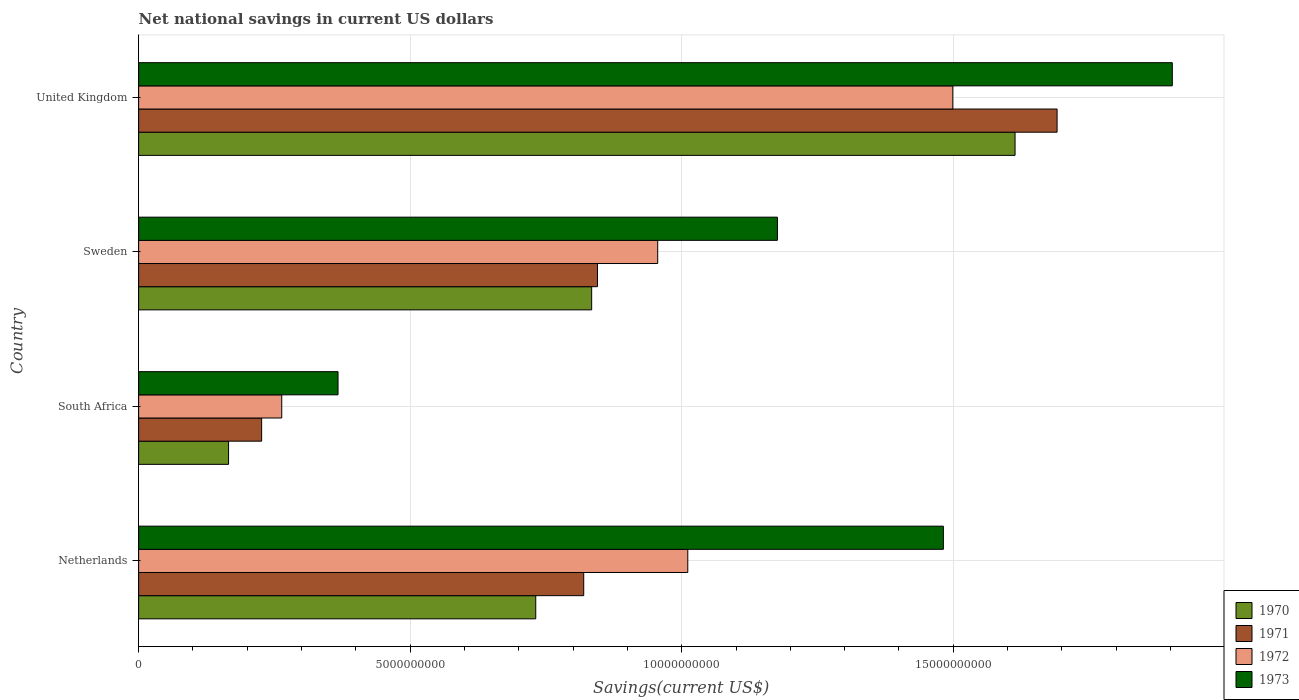How many different coloured bars are there?
Your response must be concise. 4. Are the number of bars per tick equal to the number of legend labels?
Give a very brief answer. Yes. Are the number of bars on each tick of the Y-axis equal?
Make the answer very short. Yes. How many bars are there on the 2nd tick from the bottom?
Offer a terse response. 4. What is the label of the 1st group of bars from the top?
Ensure brevity in your answer.  United Kingdom. In how many cases, is the number of bars for a given country not equal to the number of legend labels?
Your answer should be compact. 0. What is the net national savings in 1971 in South Africa?
Give a very brief answer. 2.27e+09. Across all countries, what is the maximum net national savings in 1971?
Give a very brief answer. 1.69e+1. Across all countries, what is the minimum net national savings in 1971?
Ensure brevity in your answer.  2.27e+09. In which country was the net national savings in 1970 minimum?
Your answer should be very brief. South Africa. What is the total net national savings in 1971 in the graph?
Give a very brief answer. 3.58e+1. What is the difference between the net national savings in 1972 in Netherlands and that in United Kingdom?
Offer a terse response. -4.88e+09. What is the difference between the net national savings in 1971 in United Kingdom and the net national savings in 1972 in Netherlands?
Offer a terse response. 6.80e+09. What is the average net national savings in 1972 per country?
Your answer should be compact. 9.32e+09. What is the difference between the net national savings in 1971 and net national savings in 1970 in United Kingdom?
Keep it short and to the point. 7.74e+08. What is the ratio of the net national savings in 1970 in South Africa to that in United Kingdom?
Keep it short and to the point. 0.1. Is the net national savings in 1973 in Netherlands less than that in Sweden?
Your answer should be very brief. No. What is the difference between the highest and the second highest net national savings in 1973?
Provide a succinct answer. 4.22e+09. What is the difference between the highest and the lowest net national savings in 1972?
Make the answer very short. 1.24e+1. What does the 3rd bar from the top in Sweden represents?
Your response must be concise. 1971. Is it the case that in every country, the sum of the net national savings in 1971 and net national savings in 1970 is greater than the net national savings in 1972?
Offer a very short reply. Yes. What is the difference between two consecutive major ticks on the X-axis?
Your answer should be compact. 5.00e+09. Are the values on the major ticks of X-axis written in scientific E-notation?
Make the answer very short. No. Does the graph contain grids?
Your answer should be very brief. Yes. How many legend labels are there?
Your response must be concise. 4. What is the title of the graph?
Provide a succinct answer. Net national savings in current US dollars. Does "1972" appear as one of the legend labels in the graph?
Provide a succinct answer. Yes. What is the label or title of the X-axis?
Offer a very short reply. Savings(current US$). What is the label or title of the Y-axis?
Make the answer very short. Country. What is the Savings(current US$) of 1970 in Netherlands?
Your answer should be very brief. 7.31e+09. What is the Savings(current US$) of 1971 in Netherlands?
Keep it short and to the point. 8.20e+09. What is the Savings(current US$) in 1972 in Netherlands?
Keep it short and to the point. 1.01e+1. What is the Savings(current US$) in 1973 in Netherlands?
Your response must be concise. 1.48e+1. What is the Savings(current US$) of 1970 in South Africa?
Give a very brief answer. 1.66e+09. What is the Savings(current US$) of 1971 in South Africa?
Offer a very short reply. 2.27e+09. What is the Savings(current US$) of 1972 in South Africa?
Your answer should be compact. 2.64e+09. What is the Savings(current US$) of 1973 in South Africa?
Keep it short and to the point. 3.67e+09. What is the Savings(current US$) of 1970 in Sweden?
Your answer should be very brief. 8.34e+09. What is the Savings(current US$) of 1971 in Sweden?
Give a very brief answer. 8.45e+09. What is the Savings(current US$) of 1972 in Sweden?
Give a very brief answer. 9.56e+09. What is the Savings(current US$) of 1973 in Sweden?
Your answer should be very brief. 1.18e+1. What is the Savings(current US$) of 1970 in United Kingdom?
Keep it short and to the point. 1.61e+1. What is the Savings(current US$) of 1971 in United Kingdom?
Make the answer very short. 1.69e+1. What is the Savings(current US$) of 1972 in United Kingdom?
Provide a succinct answer. 1.50e+1. What is the Savings(current US$) of 1973 in United Kingdom?
Offer a very short reply. 1.90e+1. Across all countries, what is the maximum Savings(current US$) of 1970?
Offer a terse response. 1.61e+1. Across all countries, what is the maximum Savings(current US$) of 1971?
Offer a very short reply. 1.69e+1. Across all countries, what is the maximum Savings(current US$) in 1972?
Your answer should be very brief. 1.50e+1. Across all countries, what is the maximum Savings(current US$) of 1973?
Offer a terse response. 1.90e+1. Across all countries, what is the minimum Savings(current US$) of 1970?
Your answer should be very brief. 1.66e+09. Across all countries, what is the minimum Savings(current US$) in 1971?
Offer a very short reply. 2.27e+09. Across all countries, what is the minimum Savings(current US$) of 1972?
Keep it short and to the point. 2.64e+09. Across all countries, what is the minimum Savings(current US$) in 1973?
Your answer should be compact. 3.67e+09. What is the total Savings(current US$) of 1970 in the graph?
Your response must be concise. 3.34e+1. What is the total Savings(current US$) of 1971 in the graph?
Provide a succinct answer. 3.58e+1. What is the total Savings(current US$) in 1972 in the graph?
Provide a succinct answer. 3.73e+1. What is the total Savings(current US$) of 1973 in the graph?
Give a very brief answer. 4.93e+1. What is the difference between the Savings(current US$) in 1970 in Netherlands and that in South Africa?
Offer a terse response. 5.66e+09. What is the difference between the Savings(current US$) of 1971 in Netherlands and that in South Africa?
Give a very brief answer. 5.93e+09. What is the difference between the Savings(current US$) in 1972 in Netherlands and that in South Africa?
Your answer should be compact. 7.48e+09. What is the difference between the Savings(current US$) in 1973 in Netherlands and that in South Africa?
Give a very brief answer. 1.11e+1. What is the difference between the Savings(current US$) of 1970 in Netherlands and that in Sweden?
Ensure brevity in your answer.  -1.03e+09. What is the difference between the Savings(current US$) of 1971 in Netherlands and that in Sweden?
Offer a terse response. -2.53e+08. What is the difference between the Savings(current US$) in 1972 in Netherlands and that in Sweden?
Your answer should be very brief. 5.54e+08. What is the difference between the Savings(current US$) in 1973 in Netherlands and that in Sweden?
Offer a very short reply. 3.06e+09. What is the difference between the Savings(current US$) in 1970 in Netherlands and that in United Kingdom?
Keep it short and to the point. -8.83e+09. What is the difference between the Savings(current US$) of 1971 in Netherlands and that in United Kingdom?
Your answer should be compact. -8.72e+09. What is the difference between the Savings(current US$) in 1972 in Netherlands and that in United Kingdom?
Provide a short and direct response. -4.88e+09. What is the difference between the Savings(current US$) in 1973 in Netherlands and that in United Kingdom?
Offer a very short reply. -4.22e+09. What is the difference between the Savings(current US$) in 1970 in South Africa and that in Sweden?
Provide a succinct answer. -6.69e+09. What is the difference between the Savings(current US$) of 1971 in South Africa and that in Sweden?
Ensure brevity in your answer.  -6.18e+09. What is the difference between the Savings(current US$) of 1972 in South Africa and that in Sweden?
Your response must be concise. -6.92e+09. What is the difference between the Savings(current US$) of 1973 in South Africa and that in Sweden?
Your answer should be very brief. -8.09e+09. What is the difference between the Savings(current US$) of 1970 in South Africa and that in United Kingdom?
Provide a short and direct response. -1.45e+1. What is the difference between the Savings(current US$) in 1971 in South Africa and that in United Kingdom?
Give a very brief answer. -1.46e+1. What is the difference between the Savings(current US$) of 1972 in South Africa and that in United Kingdom?
Provide a succinct answer. -1.24e+1. What is the difference between the Savings(current US$) of 1973 in South Africa and that in United Kingdom?
Your answer should be compact. -1.54e+1. What is the difference between the Savings(current US$) of 1970 in Sweden and that in United Kingdom?
Make the answer very short. -7.80e+09. What is the difference between the Savings(current US$) in 1971 in Sweden and that in United Kingdom?
Your response must be concise. -8.46e+09. What is the difference between the Savings(current US$) in 1972 in Sweden and that in United Kingdom?
Provide a short and direct response. -5.43e+09. What is the difference between the Savings(current US$) in 1973 in Sweden and that in United Kingdom?
Your answer should be compact. -7.27e+09. What is the difference between the Savings(current US$) in 1970 in Netherlands and the Savings(current US$) in 1971 in South Africa?
Offer a terse response. 5.05e+09. What is the difference between the Savings(current US$) in 1970 in Netherlands and the Savings(current US$) in 1972 in South Africa?
Provide a succinct answer. 4.68e+09. What is the difference between the Savings(current US$) in 1970 in Netherlands and the Savings(current US$) in 1973 in South Africa?
Offer a terse response. 3.64e+09. What is the difference between the Savings(current US$) in 1971 in Netherlands and the Savings(current US$) in 1972 in South Africa?
Your answer should be very brief. 5.56e+09. What is the difference between the Savings(current US$) in 1971 in Netherlands and the Savings(current US$) in 1973 in South Africa?
Ensure brevity in your answer.  4.52e+09. What is the difference between the Savings(current US$) of 1972 in Netherlands and the Savings(current US$) of 1973 in South Africa?
Ensure brevity in your answer.  6.44e+09. What is the difference between the Savings(current US$) of 1970 in Netherlands and the Savings(current US$) of 1971 in Sweden?
Give a very brief answer. -1.14e+09. What is the difference between the Savings(current US$) in 1970 in Netherlands and the Savings(current US$) in 1972 in Sweden?
Offer a very short reply. -2.25e+09. What is the difference between the Savings(current US$) of 1970 in Netherlands and the Savings(current US$) of 1973 in Sweden?
Offer a very short reply. -4.45e+09. What is the difference between the Savings(current US$) of 1971 in Netherlands and the Savings(current US$) of 1972 in Sweden?
Offer a terse response. -1.36e+09. What is the difference between the Savings(current US$) of 1971 in Netherlands and the Savings(current US$) of 1973 in Sweden?
Offer a very short reply. -3.57e+09. What is the difference between the Savings(current US$) of 1972 in Netherlands and the Savings(current US$) of 1973 in Sweden?
Your answer should be very brief. -1.65e+09. What is the difference between the Savings(current US$) in 1970 in Netherlands and the Savings(current US$) in 1971 in United Kingdom?
Your response must be concise. -9.60e+09. What is the difference between the Savings(current US$) in 1970 in Netherlands and the Savings(current US$) in 1972 in United Kingdom?
Make the answer very short. -7.68e+09. What is the difference between the Savings(current US$) in 1970 in Netherlands and the Savings(current US$) in 1973 in United Kingdom?
Keep it short and to the point. -1.17e+1. What is the difference between the Savings(current US$) in 1971 in Netherlands and the Savings(current US$) in 1972 in United Kingdom?
Keep it short and to the point. -6.80e+09. What is the difference between the Savings(current US$) of 1971 in Netherlands and the Savings(current US$) of 1973 in United Kingdom?
Make the answer very short. -1.08e+1. What is the difference between the Savings(current US$) of 1972 in Netherlands and the Savings(current US$) of 1973 in United Kingdom?
Give a very brief answer. -8.92e+09. What is the difference between the Savings(current US$) in 1970 in South Africa and the Savings(current US$) in 1971 in Sweden?
Your answer should be compact. -6.79e+09. What is the difference between the Savings(current US$) of 1970 in South Africa and the Savings(current US$) of 1972 in Sweden?
Provide a short and direct response. -7.90e+09. What is the difference between the Savings(current US$) in 1970 in South Africa and the Savings(current US$) in 1973 in Sweden?
Offer a very short reply. -1.01e+1. What is the difference between the Savings(current US$) in 1971 in South Africa and the Savings(current US$) in 1972 in Sweden?
Keep it short and to the point. -7.29e+09. What is the difference between the Savings(current US$) of 1971 in South Africa and the Savings(current US$) of 1973 in Sweden?
Your answer should be very brief. -9.50e+09. What is the difference between the Savings(current US$) of 1972 in South Africa and the Savings(current US$) of 1973 in Sweden?
Offer a terse response. -9.13e+09. What is the difference between the Savings(current US$) in 1970 in South Africa and the Savings(current US$) in 1971 in United Kingdom?
Give a very brief answer. -1.53e+1. What is the difference between the Savings(current US$) in 1970 in South Africa and the Savings(current US$) in 1972 in United Kingdom?
Offer a terse response. -1.33e+1. What is the difference between the Savings(current US$) of 1970 in South Africa and the Savings(current US$) of 1973 in United Kingdom?
Your answer should be very brief. -1.74e+1. What is the difference between the Savings(current US$) in 1971 in South Africa and the Savings(current US$) in 1972 in United Kingdom?
Offer a very short reply. -1.27e+1. What is the difference between the Savings(current US$) in 1971 in South Africa and the Savings(current US$) in 1973 in United Kingdom?
Keep it short and to the point. -1.68e+1. What is the difference between the Savings(current US$) in 1972 in South Africa and the Savings(current US$) in 1973 in United Kingdom?
Your answer should be very brief. -1.64e+1. What is the difference between the Savings(current US$) in 1970 in Sweden and the Savings(current US$) in 1971 in United Kingdom?
Provide a short and direct response. -8.57e+09. What is the difference between the Savings(current US$) of 1970 in Sweden and the Savings(current US$) of 1972 in United Kingdom?
Give a very brief answer. -6.65e+09. What is the difference between the Savings(current US$) of 1970 in Sweden and the Savings(current US$) of 1973 in United Kingdom?
Offer a very short reply. -1.07e+1. What is the difference between the Savings(current US$) in 1971 in Sweden and the Savings(current US$) in 1972 in United Kingdom?
Provide a succinct answer. -6.54e+09. What is the difference between the Savings(current US$) in 1971 in Sweden and the Savings(current US$) in 1973 in United Kingdom?
Offer a terse response. -1.06e+1. What is the difference between the Savings(current US$) of 1972 in Sweden and the Savings(current US$) of 1973 in United Kingdom?
Provide a succinct answer. -9.48e+09. What is the average Savings(current US$) of 1970 per country?
Your answer should be compact. 8.36e+09. What is the average Savings(current US$) of 1971 per country?
Make the answer very short. 8.96e+09. What is the average Savings(current US$) in 1972 per country?
Your answer should be compact. 9.32e+09. What is the average Savings(current US$) of 1973 per country?
Your response must be concise. 1.23e+1. What is the difference between the Savings(current US$) of 1970 and Savings(current US$) of 1971 in Netherlands?
Your answer should be compact. -8.83e+08. What is the difference between the Savings(current US$) of 1970 and Savings(current US$) of 1972 in Netherlands?
Offer a terse response. -2.80e+09. What is the difference between the Savings(current US$) in 1970 and Savings(current US$) in 1973 in Netherlands?
Ensure brevity in your answer.  -7.51e+09. What is the difference between the Savings(current US$) in 1971 and Savings(current US$) in 1972 in Netherlands?
Provide a short and direct response. -1.92e+09. What is the difference between the Savings(current US$) in 1971 and Savings(current US$) in 1973 in Netherlands?
Your answer should be compact. -6.62e+09. What is the difference between the Savings(current US$) in 1972 and Savings(current US$) in 1973 in Netherlands?
Your answer should be very brief. -4.71e+09. What is the difference between the Savings(current US$) in 1970 and Savings(current US$) in 1971 in South Africa?
Ensure brevity in your answer.  -6.09e+08. What is the difference between the Savings(current US$) in 1970 and Savings(current US$) in 1972 in South Africa?
Give a very brief answer. -9.79e+08. What is the difference between the Savings(current US$) in 1970 and Savings(current US$) in 1973 in South Africa?
Your answer should be compact. -2.02e+09. What is the difference between the Savings(current US$) of 1971 and Savings(current US$) of 1972 in South Africa?
Provide a succinct answer. -3.70e+08. What is the difference between the Savings(current US$) in 1971 and Savings(current US$) in 1973 in South Africa?
Offer a terse response. -1.41e+09. What is the difference between the Savings(current US$) of 1972 and Savings(current US$) of 1973 in South Africa?
Your response must be concise. -1.04e+09. What is the difference between the Savings(current US$) of 1970 and Savings(current US$) of 1971 in Sweden?
Offer a terse response. -1.07e+08. What is the difference between the Savings(current US$) of 1970 and Savings(current US$) of 1972 in Sweden?
Make the answer very short. -1.22e+09. What is the difference between the Savings(current US$) of 1970 and Savings(current US$) of 1973 in Sweden?
Provide a short and direct response. -3.42e+09. What is the difference between the Savings(current US$) in 1971 and Savings(current US$) in 1972 in Sweden?
Make the answer very short. -1.11e+09. What is the difference between the Savings(current US$) of 1971 and Savings(current US$) of 1973 in Sweden?
Keep it short and to the point. -3.31e+09. What is the difference between the Savings(current US$) of 1972 and Savings(current US$) of 1973 in Sweden?
Ensure brevity in your answer.  -2.20e+09. What is the difference between the Savings(current US$) in 1970 and Savings(current US$) in 1971 in United Kingdom?
Provide a succinct answer. -7.74e+08. What is the difference between the Savings(current US$) of 1970 and Savings(current US$) of 1972 in United Kingdom?
Provide a short and direct response. 1.15e+09. What is the difference between the Savings(current US$) of 1970 and Savings(current US$) of 1973 in United Kingdom?
Offer a terse response. -2.90e+09. What is the difference between the Savings(current US$) in 1971 and Savings(current US$) in 1972 in United Kingdom?
Provide a short and direct response. 1.92e+09. What is the difference between the Savings(current US$) of 1971 and Savings(current US$) of 1973 in United Kingdom?
Give a very brief answer. -2.12e+09. What is the difference between the Savings(current US$) in 1972 and Savings(current US$) in 1973 in United Kingdom?
Provide a short and direct response. -4.04e+09. What is the ratio of the Savings(current US$) in 1970 in Netherlands to that in South Africa?
Offer a very short reply. 4.42. What is the ratio of the Savings(current US$) of 1971 in Netherlands to that in South Africa?
Make the answer very short. 3.62. What is the ratio of the Savings(current US$) in 1972 in Netherlands to that in South Africa?
Ensure brevity in your answer.  3.84. What is the ratio of the Savings(current US$) in 1973 in Netherlands to that in South Africa?
Offer a terse response. 4.04. What is the ratio of the Savings(current US$) of 1970 in Netherlands to that in Sweden?
Provide a short and direct response. 0.88. What is the ratio of the Savings(current US$) of 1972 in Netherlands to that in Sweden?
Make the answer very short. 1.06. What is the ratio of the Savings(current US$) of 1973 in Netherlands to that in Sweden?
Offer a very short reply. 1.26. What is the ratio of the Savings(current US$) of 1970 in Netherlands to that in United Kingdom?
Offer a very short reply. 0.45. What is the ratio of the Savings(current US$) of 1971 in Netherlands to that in United Kingdom?
Your response must be concise. 0.48. What is the ratio of the Savings(current US$) of 1972 in Netherlands to that in United Kingdom?
Ensure brevity in your answer.  0.67. What is the ratio of the Savings(current US$) in 1973 in Netherlands to that in United Kingdom?
Keep it short and to the point. 0.78. What is the ratio of the Savings(current US$) of 1970 in South Africa to that in Sweden?
Give a very brief answer. 0.2. What is the ratio of the Savings(current US$) in 1971 in South Africa to that in Sweden?
Give a very brief answer. 0.27. What is the ratio of the Savings(current US$) in 1972 in South Africa to that in Sweden?
Provide a short and direct response. 0.28. What is the ratio of the Savings(current US$) in 1973 in South Africa to that in Sweden?
Provide a short and direct response. 0.31. What is the ratio of the Savings(current US$) of 1970 in South Africa to that in United Kingdom?
Give a very brief answer. 0.1. What is the ratio of the Savings(current US$) in 1971 in South Africa to that in United Kingdom?
Offer a terse response. 0.13. What is the ratio of the Savings(current US$) in 1972 in South Africa to that in United Kingdom?
Offer a very short reply. 0.18. What is the ratio of the Savings(current US$) of 1973 in South Africa to that in United Kingdom?
Make the answer very short. 0.19. What is the ratio of the Savings(current US$) of 1970 in Sweden to that in United Kingdom?
Your response must be concise. 0.52. What is the ratio of the Savings(current US$) of 1971 in Sweden to that in United Kingdom?
Ensure brevity in your answer.  0.5. What is the ratio of the Savings(current US$) in 1972 in Sweden to that in United Kingdom?
Make the answer very short. 0.64. What is the ratio of the Savings(current US$) of 1973 in Sweden to that in United Kingdom?
Provide a short and direct response. 0.62. What is the difference between the highest and the second highest Savings(current US$) of 1970?
Your answer should be compact. 7.80e+09. What is the difference between the highest and the second highest Savings(current US$) in 1971?
Give a very brief answer. 8.46e+09. What is the difference between the highest and the second highest Savings(current US$) in 1972?
Make the answer very short. 4.88e+09. What is the difference between the highest and the second highest Savings(current US$) in 1973?
Your response must be concise. 4.22e+09. What is the difference between the highest and the lowest Savings(current US$) of 1970?
Offer a terse response. 1.45e+1. What is the difference between the highest and the lowest Savings(current US$) of 1971?
Keep it short and to the point. 1.46e+1. What is the difference between the highest and the lowest Savings(current US$) in 1972?
Provide a short and direct response. 1.24e+1. What is the difference between the highest and the lowest Savings(current US$) in 1973?
Your answer should be compact. 1.54e+1. 